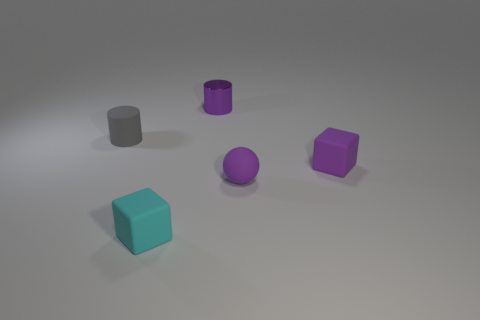Is the shape of the gray thing the same as the tiny shiny thing?
Offer a terse response. Yes. What is the size of the object that is behind the gray rubber cylinder?
Make the answer very short. Small. Is there a tiny matte block of the same color as the small metal cylinder?
Ensure brevity in your answer.  Yes. Is the size of the cylinder that is to the right of the rubber cylinder the same as the tiny purple ball?
Your response must be concise. Yes. What is the color of the rubber cylinder?
Your answer should be very brief. Gray. There is a cylinder left of the tiny purple object that is behind the tiny gray cylinder; what color is it?
Give a very brief answer. Gray. Are there any blue blocks made of the same material as the small gray cylinder?
Provide a succinct answer. No. There is a gray object that is on the left side of the small cube to the right of the shiny cylinder; what is its material?
Your answer should be very brief. Rubber. What number of purple shiny objects have the same shape as the small cyan rubber thing?
Offer a very short reply. 0. The tiny cyan matte object is what shape?
Offer a terse response. Cube. 